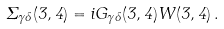<formula> <loc_0><loc_0><loc_500><loc_500>\Sigma _ { \gamma \delta } ( 3 , 4 ) = i G _ { \gamma \delta } ( 3 , 4 ) W ( 3 , 4 ) \, .</formula> 